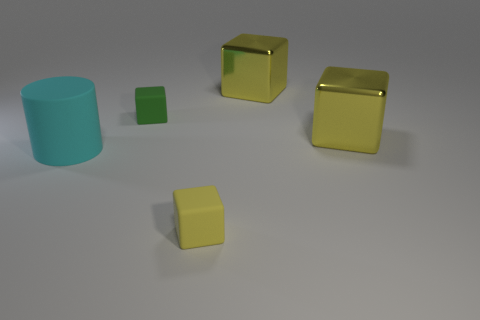How many yellow cubes must be subtracted to get 1 yellow cubes? 2 Add 3 green things. How many objects exist? 8 Subtract all small yellow matte cubes. How many cubes are left? 3 Subtract all green blocks. How many blocks are left? 3 Subtract all cylinders. How many objects are left? 4 Subtract 1 blocks. How many blocks are left? 3 Subtract all cyan spheres. How many green cubes are left? 1 Subtract all big yellow objects. Subtract all large yellow metallic things. How many objects are left? 1 Add 5 large matte things. How many large matte things are left? 6 Add 5 large blocks. How many large blocks exist? 7 